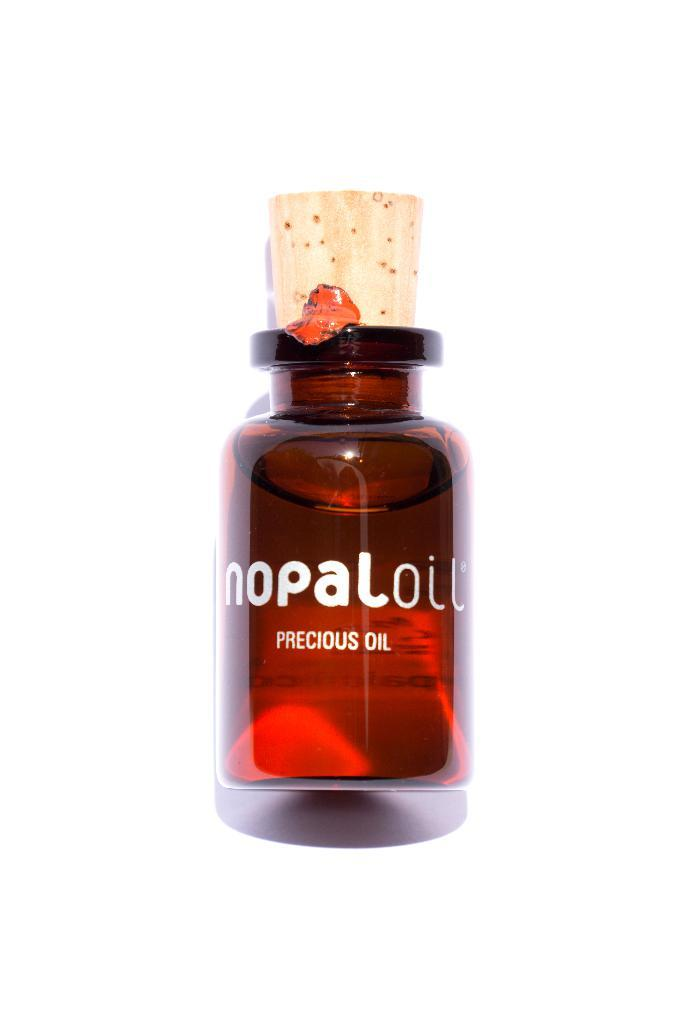<image>
Write a terse but informative summary of the picture. A small bottle of a precious oil that is red with a light brown cork at top. 